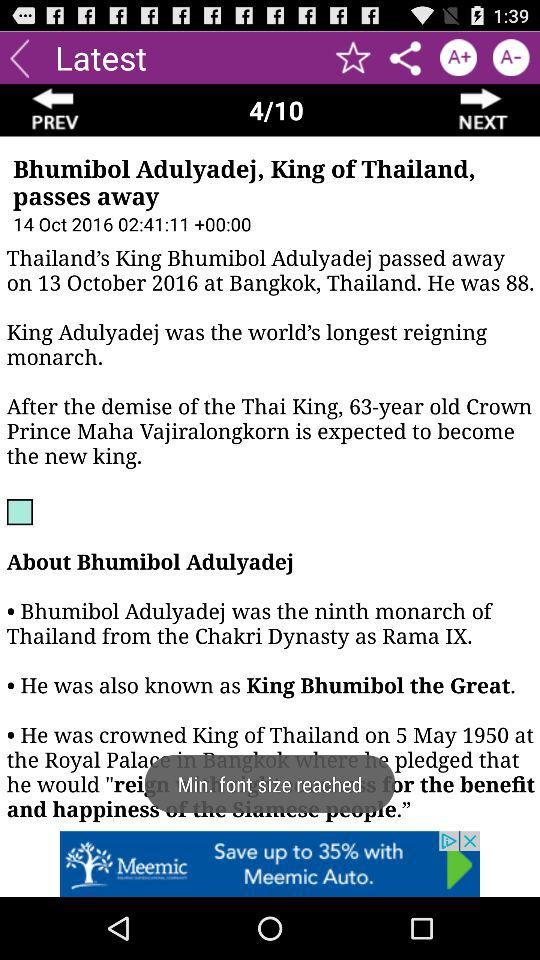Who was the King of Thailand? The King of Thailand was Bhumibol Adulyadej. 